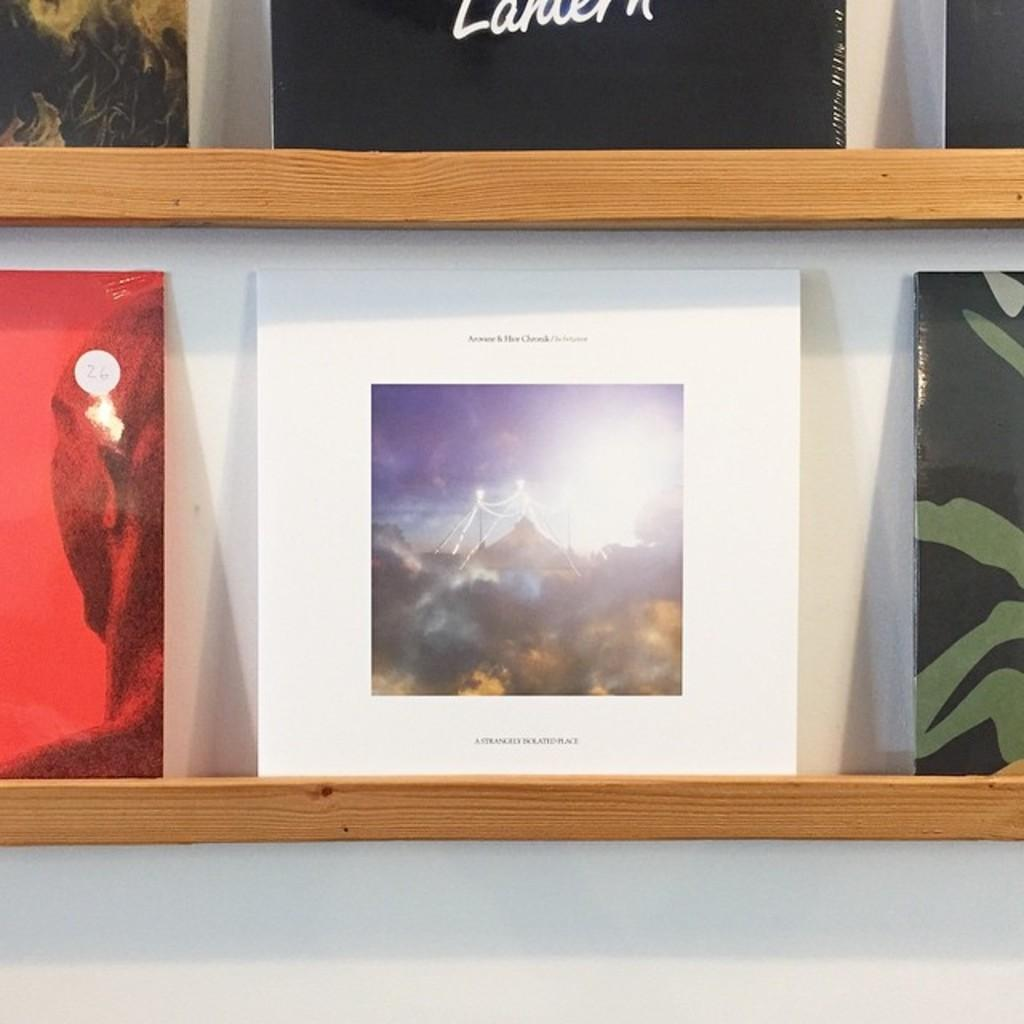<image>
Present a compact description of the photo's key features. Two thin wooded book shelves holding an assortment of books with a white bordered book on prominent display. 